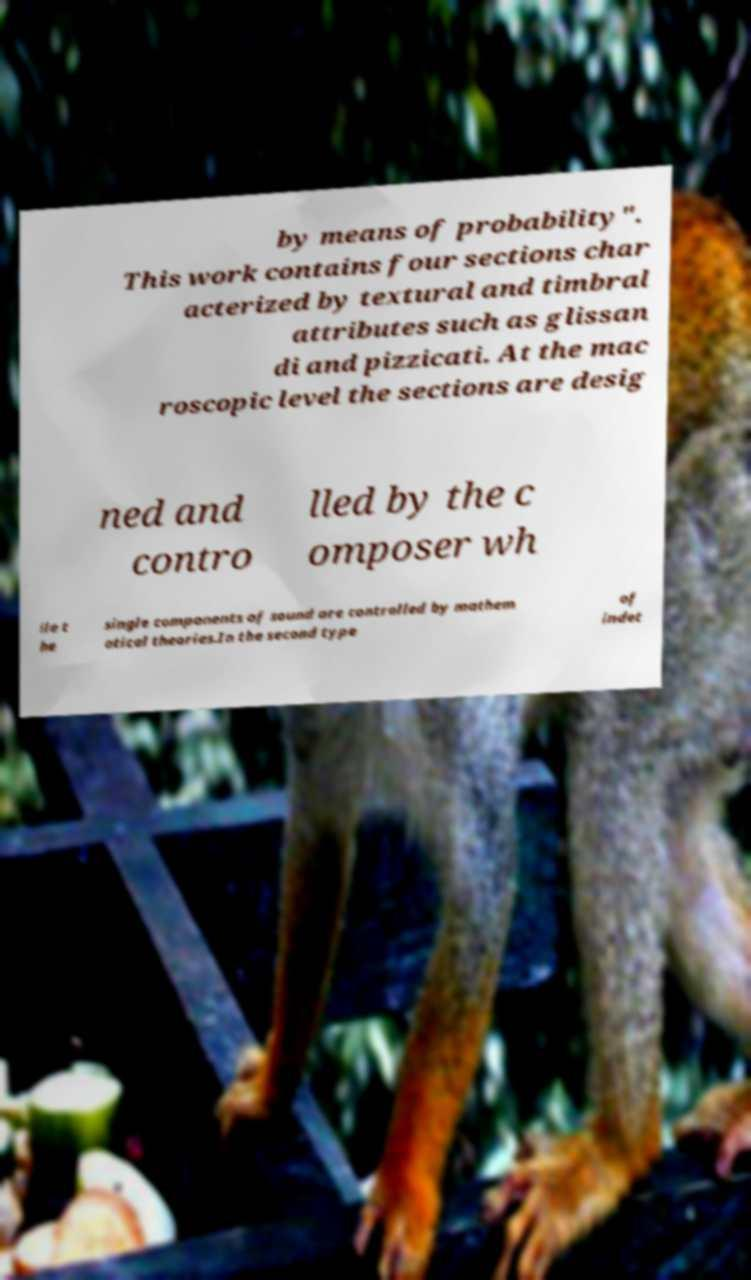Could you assist in decoding the text presented in this image and type it out clearly? by means of probability". This work contains four sections char acterized by textural and timbral attributes such as glissan di and pizzicati. At the mac roscopic level the sections are desig ned and contro lled by the c omposer wh ile t he single components of sound are controlled by mathem atical theories.In the second type of indet 